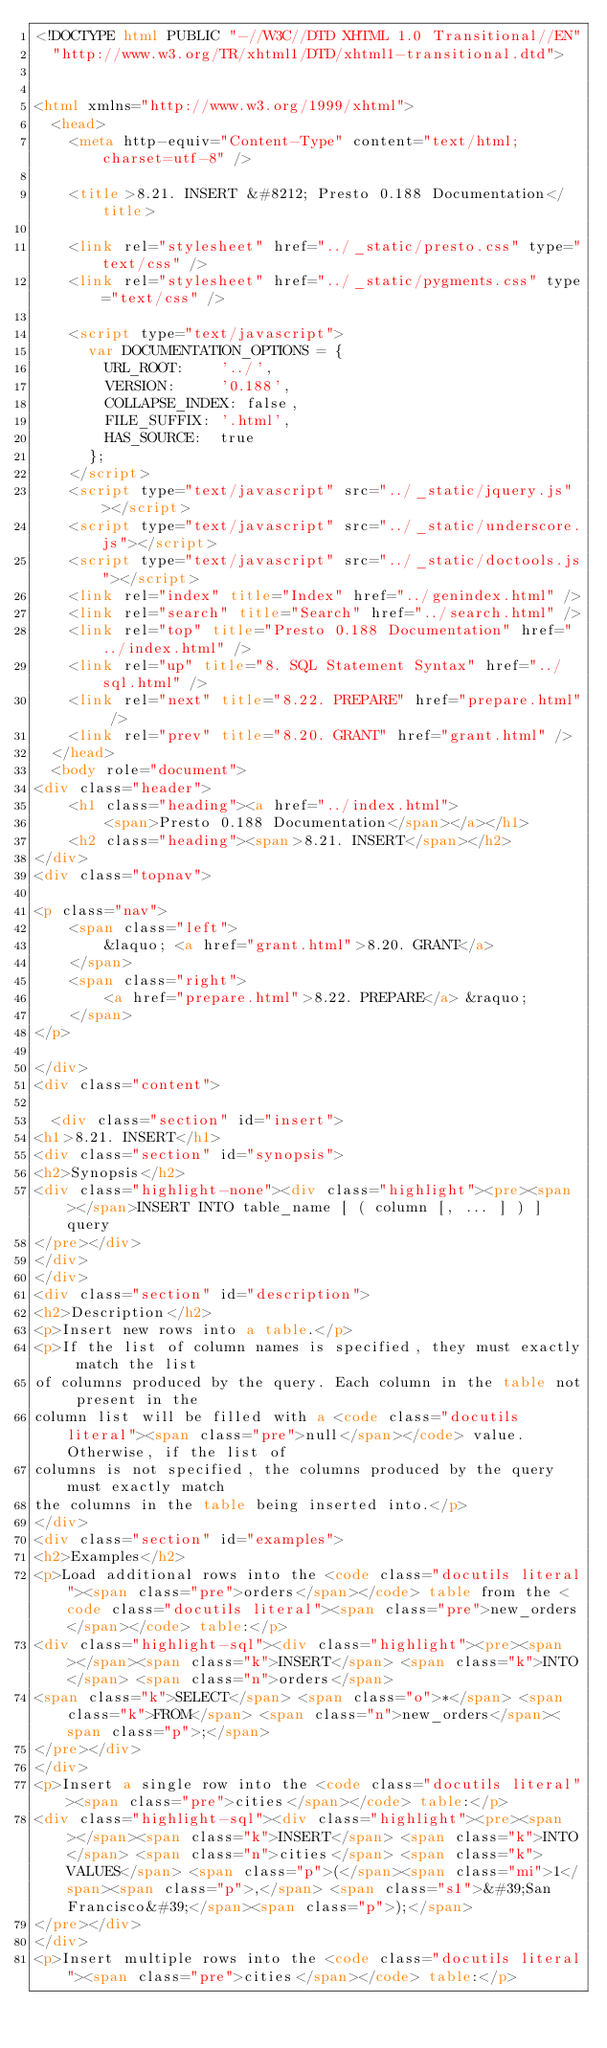<code> <loc_0><loc_0><loc_500><loc_500><_HTML_><!DOCTYPE html PUBLIC "-//W3C//DTD XHTML 1.0 Transitional//EN"
  "http://www.w3.org/TR/xhtml1/DTD/xhtml1-transitional.dtd">


<html xmlns="http://www.w3.org/1999/xhtml">
  <head>
    <meta http-equiv="Content-Type" content="text/html; charset=utf-8" />
    
    <title>8.21. INSERT &#8212; Presto 0.188 Documentation</title>
    
    <link rel="stylesheet" href="../_static/presto.css" type="text/css" />
    <link rel="stylesheet" href="../_static/pygments.css" type="text/css" />
    
    <script type="text/javascript">
      var DOCUMENTATION_OPTIONS = {
        URL_ROOT:    '../',
        VERSION:     '0.188',
        COLLAPSE_INDEX: false,
        FILE_SUFFIX: '.html',
        HAS_SOURCE:  true
      };
    </script>
    <script type="text/javascript" src="../_static/jquery.js"></script>
    <script type="text/javascript" src="../_static/underscore.js"></script>
    <script type="text/javascript" src="../_static/doctools.js"></script>
    <link rel="index" title="Index" href="../genindex.html" />
    <link rel="search" title="Search" href="../search.html" />
    <link rel="top" title="Presto 0.188 Documentation" href="../index.html" />
    <link rel="up" title="8. SQL Statement Syntax" href="../sql.html" />
    <link rel="next" title="8.22. PREPARE" href="prepare.html" />
    <link rel="prev" title="8.20. GRANT" href="grant.html" /> 
  </head>
  <body role="document">
<div class="header">
    <h1 class="heading"><a href="../index.html">
        <span>Presto 0.188 Documentation</span></a></h1>
    <h2 class="heading"><span>8.21. INSERT</span></h2>
</div>
<div class="topnav">
    
<p class="nav">
    <span class="left">
        &laquo; <a href="grant.html">8.20. GRANT</a>
    </span>
    <span class="right">
        <a href="prepare.html">8.22. PREPARE</a> &raquo;
    </span>
</p>

</div>
<div class="content">
    
  <div class="section" id="insert">
<h1>8.21. INSERT</h1>
<div class="section" id="synopsis">
<h2>Synopsis</h2>
<div class="highlight-none"><div class="highlight"><pre><span></span>INSERT INTO table_name [ ( column [, ... ] ) ] query
</pre></div>
</div>
</div>
<div class="section" id="description">
<h2>Description</h2>
<p>Insert new rows into a table.</p>
<p>If the list of column names is specified, they must exactly match the list
of columns produced by the query. Each column in the table not present in the
column list will be filled with a <code class="docutils literal"><span class="pre">null</span></code> value. Otherwise, if the list of
columns is not specified, the columns produced by the query must exactly match
the columns in the table being inserted into.</p>
</div>
<div class="section" id="examples">
<h2>Examples</h2>
<p>Load additional rows into the <code class="docutils literal"><span class="pre">orders</span></code> table from the <code class="docutils literal"><span class="pre">new_orders</span></code> table:</p>
<div class="highlight-sql"><div class="highlight"><pre><span></span><span class="k">INSERT</span> <span class="k">INTO</span> <span class="n">orders</span>
<span class="k">SELECT</span> <span class="o">*</span> <span class="k">FROM</span> <span class="n">new_orders</span><span class="p">;</span>
</pre></div>
</div>
<p>Insert a single row into the <code class="docutils literal"><span class="pre">cities</span></code> table:</p>
<div class="highlight-sql"><div class="highlight"><pre><span></span><span class="k">INSERT</span> <span class="k">INTO</span> <span class="n">cities</span> <span class="k">VALUES</span> <span class="p">(</span><span class="mi">1</span><span class="p">,</span> <span class="s1">&#39;San Francisco&#39;</span><span class="p">);</span>
</pre></div>
</div>
<p>Insert multiple rows into the <code class="docutils literal"><span class="pre">cities</span></code> table:</p></code> 